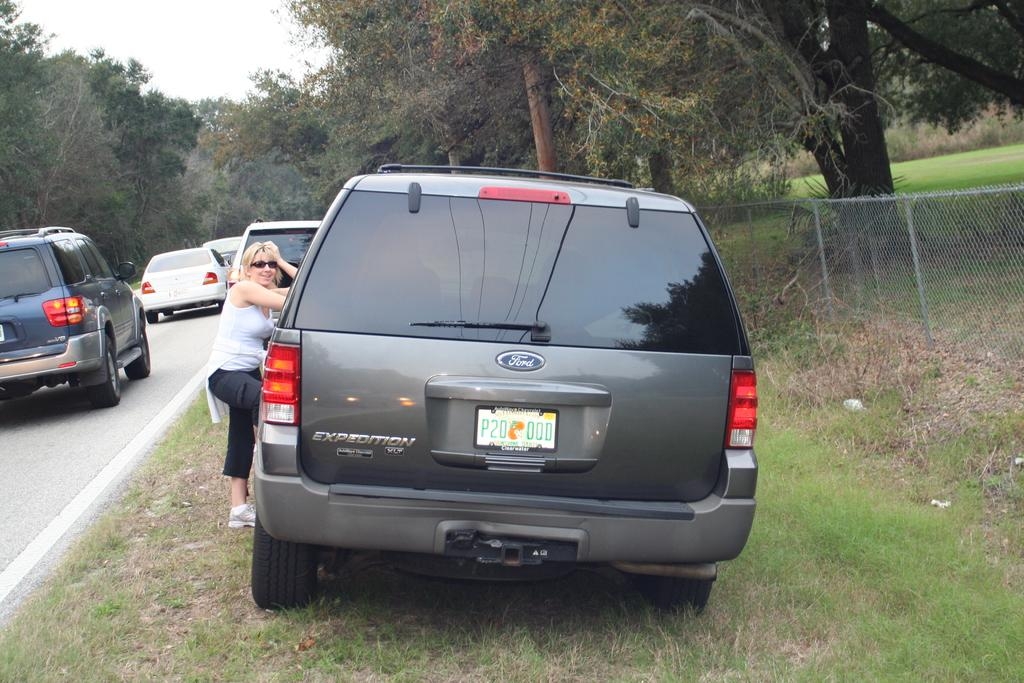<image>
Give a short and clear explanation of the subsequent image. the word Ford is on the back of the vehicle 